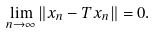<formula> <loc_0><loc_0><loc_500><loc_500>\lim _ { n \to \infty } \| x _ { n } - T x _ { n } \| = 0 .</formula> 